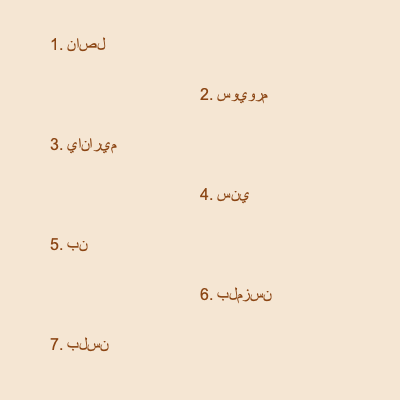Arrange the given Ottoman calligraphy tiles to form the first line of Yahya Kemal Beyatlı's famous poem "Sessiz Gemi" (Silent Ship). What is the correct order of the tiles? To solve this puzzle, we need to follow these steps:

1. Recognize that the tiles are in Ottoman Turkish script.
2. Translate each tile to modern Turkish:
   1. ناصل (nasıl) - how
   2. سويورم (seviyorum) - I love
   3. ياناريم (yanarım) - I burn
   4. سني (seni) - you
   5. بن (ben) - I
   6. بلمزسن (bilmezsin) - you don't know
   7. بلسن (bilsen) - if you knew

3. Recall the first line of Yahya Kemal Beyatlı's poem "Sessiz Gemi":
   "Artık demir almak günü gelmişse zamandan"

4. However, this line is not represented by the given tiles. The tiles actually form another famous line by Yahya Kemal Beyatlı from his poem "Telâki":
   "Bilmezsin, ben nasıl yanarım, bilsen"

5. Arrange the tiles in the correct order to form this line:
   6 (بلمزسن) - 5 (بن) - 1 (ناصل) - 3 (ياناريم) - 7 (بلسن)

Therefore, the correct order of the tiles is: 6, 5, 1, 3, 7.
Answer: 6, 5, 1, 3, 7 